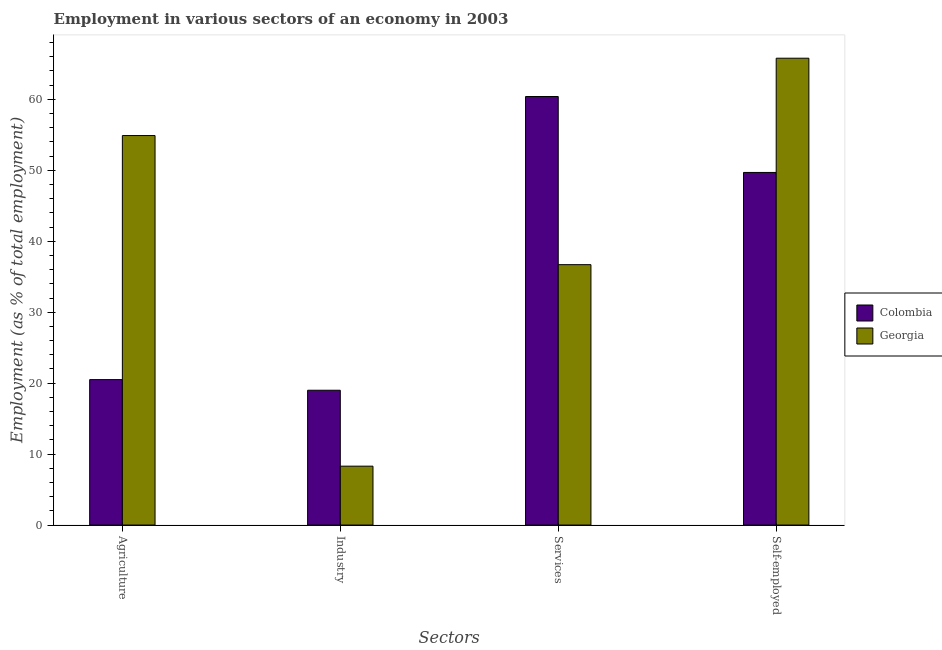Are the number of bars on each tick of the X-axis equal?
Offer a very short reply. Yes. How many bars are there on the 2nd tick from the left?
Make the answer very short. 2. What is the label of the 1st group of bars from the left?
Provide a short and direct response. Agriculture. What is the percentage of workers in agriculture in Colombia?
Your response must be concise. 20.5. Across all countries, what is the maximum percentage of workers in industry?
Make the answer very short. 19. Across all countries, what is the minimum percentage of workers in services?
Make the answer very short. 36.7. In which country was the percentage of workers in services minimum?
Offer a very short reply. Georgia. What is the total percentage of workers in services in the graph?
Your answer should be compact. 97.1. What is the difference between the percentage of workers in industry in Colombia and that in Georgia?
Keep it short and to the point. 10.7. What is the difference between the percentage of workers in industry in Georgia and the percentage of self employed workers in Colombia?
Provide a succinct answer. -41.4. What is the average percentage of workers in industry per country?
Offer a terse response. 13.65. What is the difference between the percentage of self employed workers and percentage of workers in services in Colombia?
Offer a very short reply. -10.7. In how many countries, is the percentage of self employed workers greater than 40 %?
Offer a terse response. 2. What is the ratio of the percentage of workers in services in Georgia to that in Colombia?
Your answer should be very brief. 0.61. Is the percentage of self employed workers in Colombia less than that in Georgia?
Your response must be concise. Yes. Is the difference between the percentage of workers in agriculture in Colombia and Georgia greater than the difference between the percentage of workers in services in Colombia and Georgia?
Offer a terse response. No. What is the difference between the highest and the second highest percentage of self employed workers?
Make the answer very short. 16.1. What is the difference between the highest and the lowest percentage of workers in industry?
Your response must be concise. 10.7. What does the 2nd bar from the left in Agriculture represents?
Give a very brief answer. Georgia. What does the 1st bar from the right in Services represents?
Offer a terse response. Georgia. Are all the bars in the graph horizontal?
Your answer should be compact. No. What is the difference between two consecutive major ticks on the Y-axis?
Ensure brevity in your answer.  10. Are the values on the major ticks of Y-axis written in scientific E-notation?
Your answer should be very brief. No. Does the graph contain grids?
Offer a very short reply. No. What is the title of the graph?
Give a very brief answer. Employment in various sectors of an economy in 2003. Does "Tunisia" appear as one of the legend labels in the graph?
Keep it short and to the point. No. What is the label or title of the X-axis?
Your response must be concise. Sectors. What is the label or title of the Y-axis?
Offer a terse response. Employment (as % of total employment). What is the Employment (as % of total employment) in Georgia in Agriculture?
Offer a very short reply. 54.9. What is the Employment (as % of total employment) of Georgia in Industry?
Make the answer very short. 8.3. What is the Employment (as % of total employment) of Colombia in Services?
Offer a very short reply. 60.4. What is the Employment (as % of total employment) of Georgia in Services?
Ensure brevity in your answer.  36.7. What is the Employment (as % of total employment) of Colombia in Self-employed?
Your answer should be compact. 49.7. What is the Employment (as % of total employment) in Georgia in Self-employed?
Your answer should be very brief. 65.8. Across all Sectors, what is the maximum Employment (as % of total employment) of Colombia?
Provide a succinct answer. 60.4. Across all Sectors, what is the maximum Employment (as % of total employment) in Georgia?
Give a very brief answer. 65.8. Across all Sectors, what is the minimum Employment (as % of total employment) of Georgia?
Offer a terse response. 8.3. What is the total Employment (as % of total employment) in Colombia in the graph?
Your answer should be compact. 149.6. What is the total Employment (as % of total employment) of Georgia in the graph?
Provide a succinct answer. 165.7. What is the difference between the Employment (as % of total employment) of Georgia in Agriculture and that in Industry?
Your answer should be compact. 46.6. What is the difference between the Employment (as % of total employment) in Colombia in Agriculture and that in Services?
Provide a short and direct response. -39.9. What is the difference between the Employment (as % of total employment) of Georgia in Agriculture and that in Services?
Provide a succinct answer. 18.2. What is the difference between the Employment (as % of total employment) of Colombia in Agriculture and that in Self-employed?
Give a very brief answer. -29.2. What is the difference between the Employment (as % of total employment) of Colombia in Industry and that in Services?
Keep it short and to the point. -41.4. What is the difference between the Employment (as % of total employment) in Georgia in Industry and that in Services?
Your response must be concise. -28.4. What is the difference between the Employment (as % of total employment) of Colombia in Industry and that in Self-employed?
Make the answer very short. -30.7. What is the difference between the Employment (as % of total employment) of Georgia in Industry and that in Self-employed?
Your response must be concise. -57.5. What is the difference between the Employment (as % of total employment) of Colombia in Services and that in Self-employed?
Provide a short and direct response. 10.7. What is the difference between the Employment (as % of total employment) in Georgia in Services and that in Self-employed?
Keep it short and to the point. -29.1. What is the difference between the Employment (as % of total employment) of Colombia in Agriculture and the Employment (as % of total employment) of Georgia in Industry?
Your response must be concise. 12.2. What is the difference between the Employment (as % of total employment) in Colombia in Agriculture and the Employment (as % of total employment) in Georgia in Services?
Provide a short and direct response. -16.2. What is the difference between the Employment (as % of total employment) in Colombia in Agriculture and the Employment (as % of total employment) in Georgia in Self-employed?
Offer a terse response. -45.3. What is the difference between the Employment (as % of total employment) in Colombia in Industry and the Employment (as % of total employment) in Georgia in Services?
Provide a succinct answer. -17.7. What is the difference between the Employment (as % of total employment) in Colombia in Industry and the Employment (as % of total employment) in Georgia in Self-employed?
Your response must be concise. -46.8. What is the difference between the Employment (as % of total employment) in Colombia in Services and the Employment (as % of total employment) in Georgia in Self-employed?
Make the answer very short. -5.4. What is the average Employment (as % of total employment) of Colombia per Sectors?
Offer a terse response. 37.4. What is the average Employment (as % of total employment) in Georgia per Sectors?
Your response must be concise. 41.42. What is the difference between the Employment (as % of total employment) of Colombia and Employment (as % of total employment) of Georgia in Agriculture?
Provide a succinct answer. -34.4. What is the difference between the Employment (as % of total employment) of Colombia and Employment (as % of total employment) of Georgia in Industry?
Give a very brief answer. 10.7. What is the difference between the Employment (as % of total employment) in Colombia and Employment (as % of total employment) in Georgia in Services?
Offer a terse response. 23.7. What is the difference between the Employment (as % of total employment) in Colombia and Employment (as % of total employment) in Georgia in Self-employed?
Your answer should be compact. -16.1. What is the ratio of the Employment (as % of total employment) in Colombia in Agriculture to that in Industry?
Keep it short and to the point. 1.08. What is the ratio of the Employment (as % of total employment) in Georgia in Agriculture to that in Industry?
Make the answer very short. 6.61. What is the ratio of the Employment (as % of total employment) in Colombia in Agriculture to that in Services?
Your response must be concise. 0.34. What is the ratio of the Employment (as % of total employment) of Georgia in Agriculture to that in Services?
Ensure brevity in your answer.  1.5. What is the ratio of the Employment (as % of total employment) of Colombia in Agriculture to that in Self-employed?
Provide a succinct answer. 0.41. What is the ratio of the Employment (as % of total employment) in Georgia in Agriculture to that in Self-employed?
Your answer should be very brief. 0.83. What is the ratio of the Employment (as % of total employment) in Colombia in Industry to that in Services?
Offer a very short reply. 0.31. What is the ratio of the Employment (as % of total employment) of Georgia in Industry to that in Services?
Offer a very short reply. 0.23. What is the ratio of the Employment (as % of total employment) of Colombia in Industry to that in Self-employed?
Keep it short and to the point. 0.38. What is the ratio of the Employment (as % of total employment) of Georgia in Industry to that in Self-employed?
Give a very brief answer. 0.13. What is the ratio of the Employment (as % of total employment) of Colombia in Services to that in Self-employed?
Provide a short and direct response. 1.22. What is the ratio of the Employment (as % of total employment) in Georgia in Services to that in Self-employed?
Your answer should be compact. 0.56. What is the difference between the highest and the lowest Employment (as % of total employment) of Colombia?
Your answer should be compact. 41.4. What is the difference between the highest and the lowest Employment (as % of total employment) of Georgia?
Give a very brief answer. 57.5. 